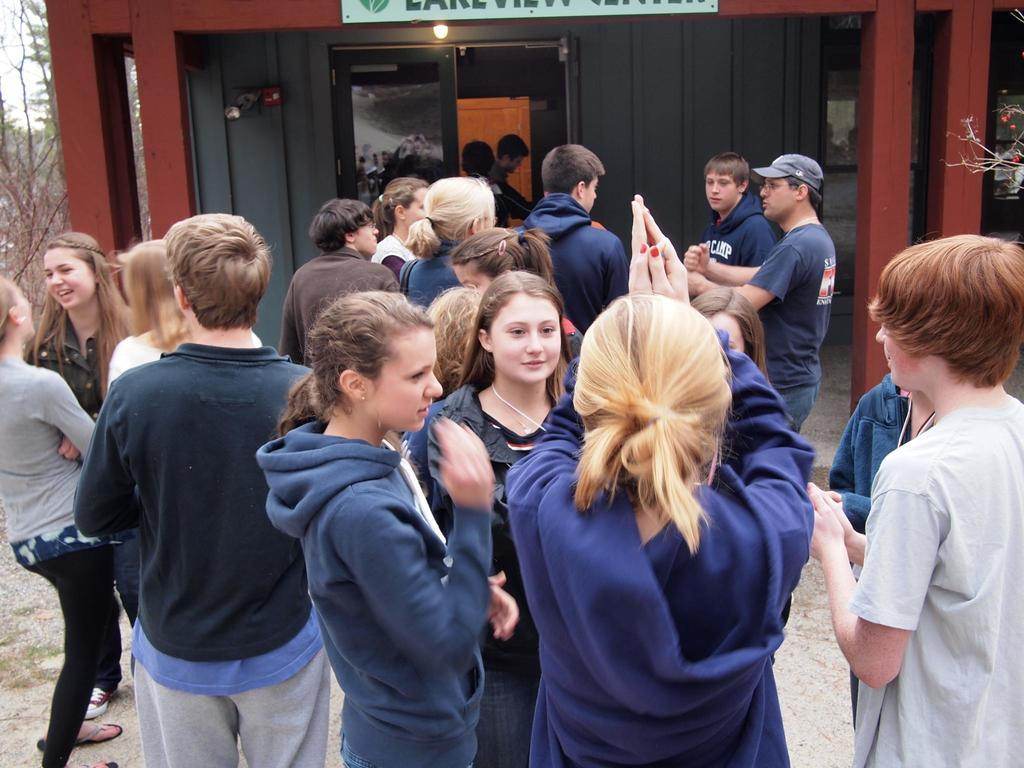What is the main focus of the image? The main focus of the image is the many people standing in the center. Can you describe the background of the image? In the background of the image, there is a shed and trees visible. How many snails can be seen crawling on the shed in the image? There are no snails visible in the image, as it only features people standing in the center and a shed with trees in the background. 